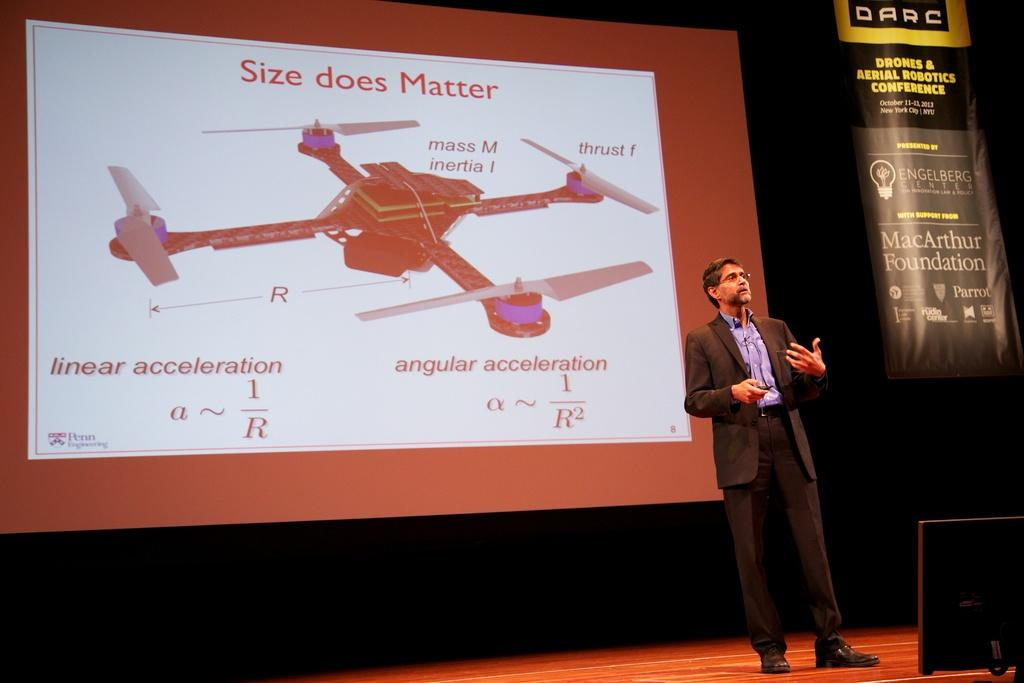Provide a one-sentence caption for the provided image. A man speaking on a stage with a picture of a drone and the words size does matter behind him on a projection screen. 